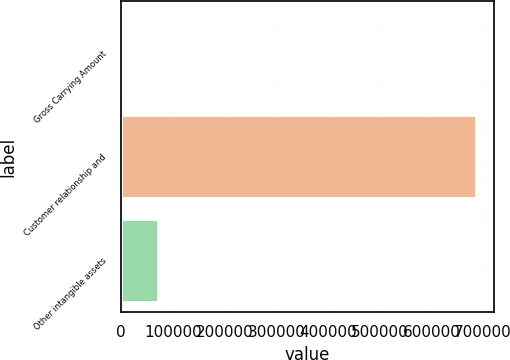Convert chart. <chart><loc_0><loc_0><loc_500><loc_500><bar_chart><fcel>Gross Carrying Amount<fcel>Customer relationship and<fcel>Other intangible assets<nl><fcel>2012<fcel>685898<fcel>70400.6<nl></chart> 